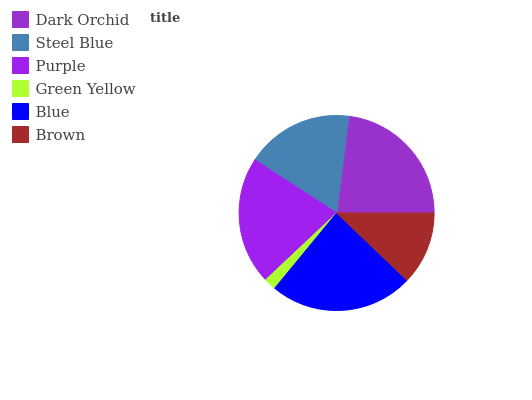Is Green Yellow the minimum?
Answer yes or no. Yes. Is Blue the maximum?
Answer yes or no. Yes. Is Steel Blue the minimum?
Answer yes or no. No. Is Steel Blue the maximum?
Answer yes or no. No. Is Dark Orchid greater than Steel Blue?
Answer yes or no. Yes. Is Steel Blue less than Dark Orchid?
Answer yes or no. Yes. Is Steel Blue greater than Dark Orchid?
Answer yes or no. No. Is Dark Orchid less than Steel Blue?
Answer yes or no. No. Is Purple the high median?
Answer yes or no. Yes. Is Steel Blue the low median?
Answer yes or no. Yes. Is Dark Orchid the high median?
Answer yes or no. No. Is Blue the low median?
Answer yes or no. No. 